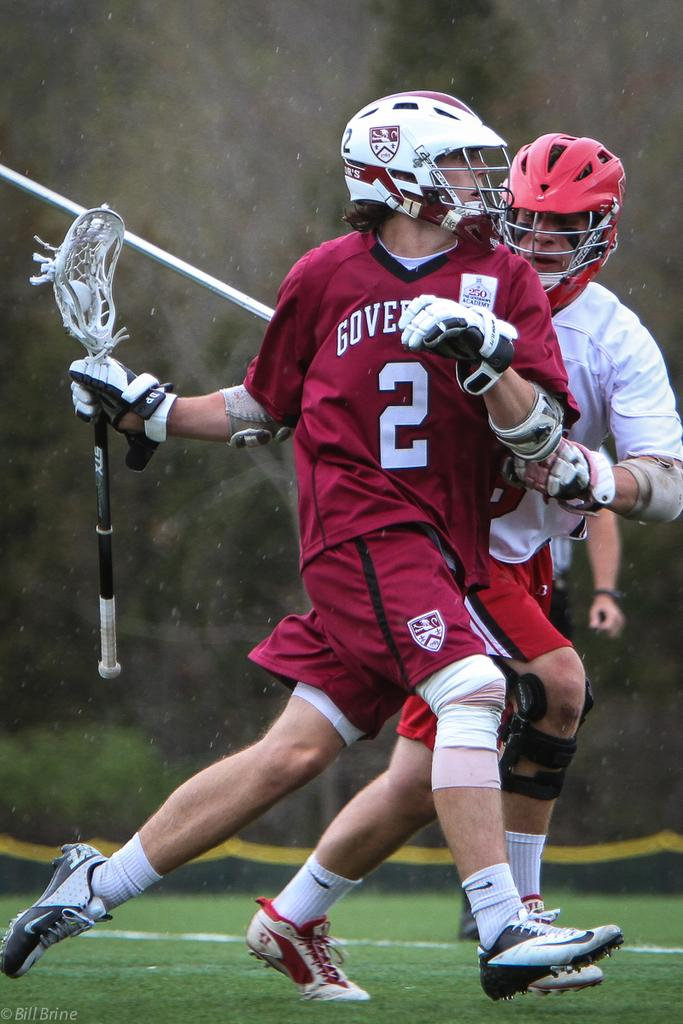<image>
Present a compact description of the photo's key features. Player number 2 is wearing a helmet and carrying a lacrosse stick. 